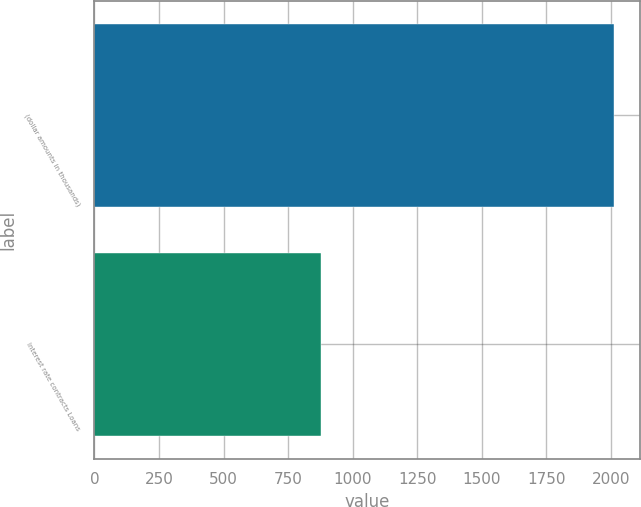Convert chart to OTSL. <chart><loc_0><loc_0><loc_500><loc_500><bar_chart><fcel>(dollar amounts in thousands)<fcel>Interest rate contracts Loans<nl><fcel>2013<fcel>878<nl></chart> 